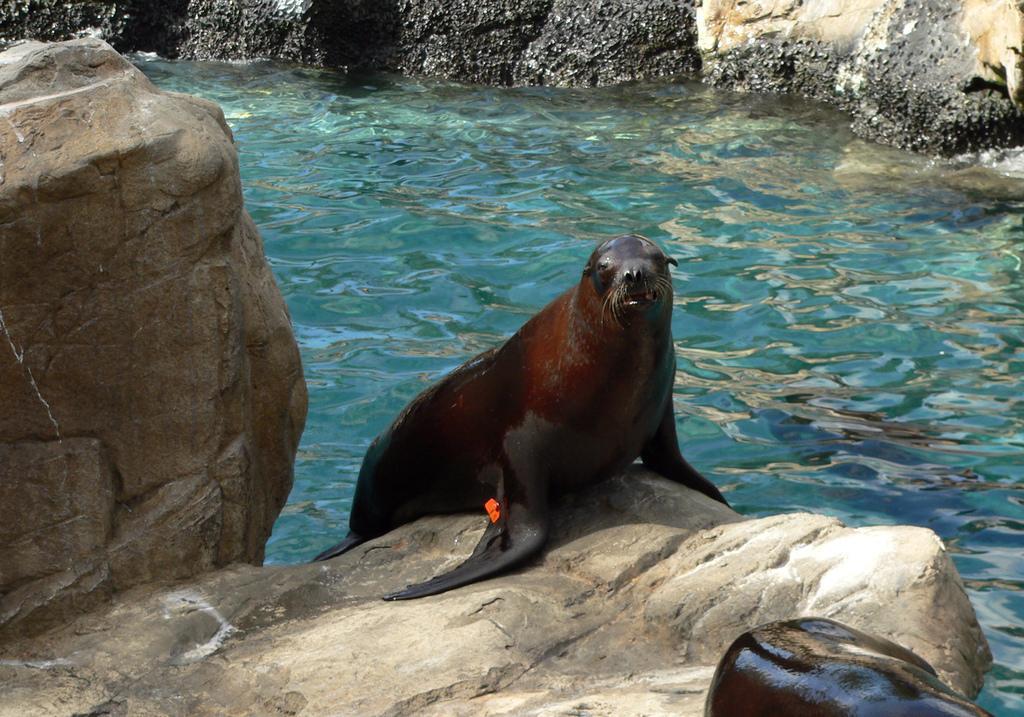Describe this image in one or two sentences. In the center of the image, we can see a water animal and in the background, there are rocks and there is water and in the front, there is another animal. 